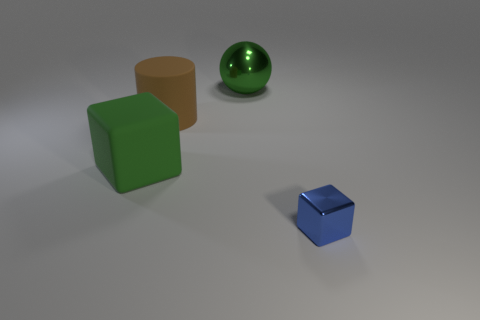Is there anything else that has the same size as the blue thing?
Provide a succinct answer. No. The green thing that is the same shape as the blue object is what size?
Offer a very short reply. Large. How many blue things have the same material as the sphere?
Ensure brevity in your answer.  1. Does the sphere have the same color as the cube that is on the left side of the large green metallic object?
Offer a very short reply. Yes. Are there more large brown objects than green things?
Ensure brevity in your answer.  No. What is the color of the small object?
Make the answer very short. Blue. Does the block that is to the left of the big green sphere have the same color as the big metallic ball?
Offer a terse response. Yes. What material is the large thing that is the same color as the metal ball?
Offer a very short reply. Rubber. How many rubber cubes are the same color as the large ball?
Provide a succinct answer. 1. Do the metallic object in front of the green block and the big green rubber thing have the same shape?
Keep it short and to the point. Yes. 